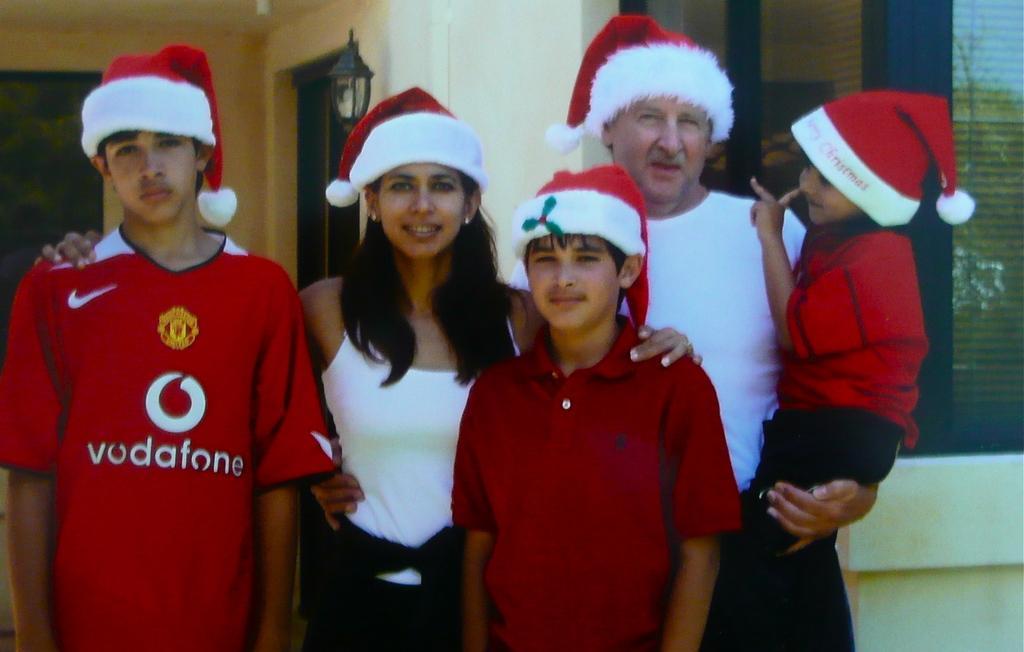Describe this image in one or two sentences. In this image there are people standing, in the background there is a house. 